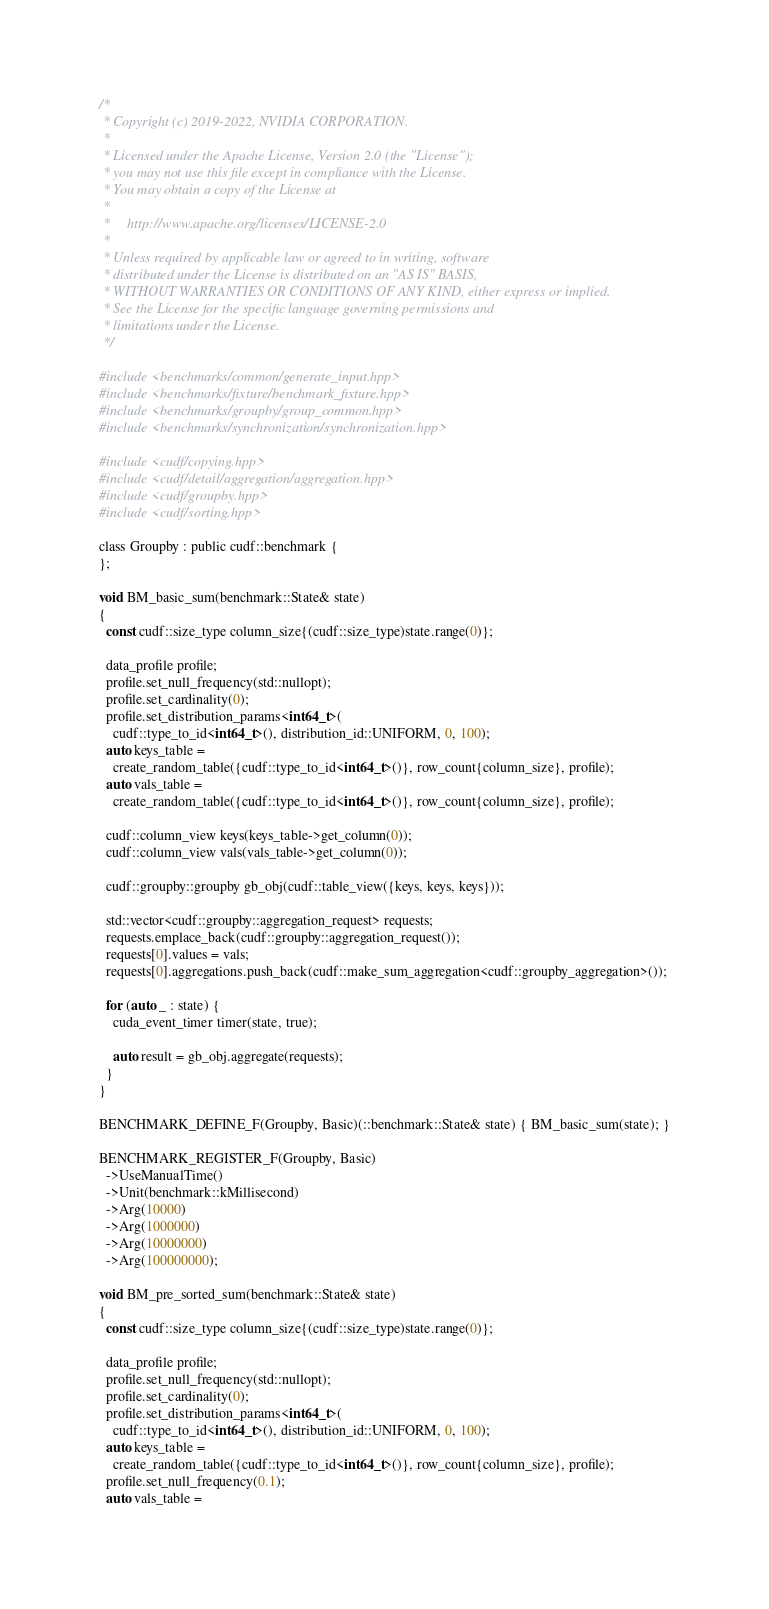Convert code to text. <code><loc_0><loc_0><loc_500><loc_500><_Cuda_>/*
 * Copyright (c) 2019-2022, NVIDIA CORPORATION.
 *
 * Licensed under the Apache License, Version 2.0 (the "License");
 * you may not use this file except in compliance with the License.
 * You may obtain a copy of the License at
 *
 *     http://www.apache.org/licenses/LICENSE-2.0
 *
 * Unless required by applicable law or agreed to in writing, software
 * distributed under the License is distributed on an "AS IS" BASIS,
 * WITHOUT WARRANTIES OR CONDITIONS OF ANY KIND, either express or implied.
 * See the License for the specific language governing permissions and
 * limitations under the License.
 */

#include <benchmarks/common/generate_input.hpp>
#include <benchmarks/fixture/benchmark_fixture.hpp>
#include <benchmarks/groupby/group_common.hpp>
#include <benchmarks/synchronization/synchronization.hpp>

#include <cudf/copying.hpp>
#include <cudf/detail/aggregation/aggregation.hpp>
#include <cudf/groupby.hpp>
#include <cudf/sorting.hpp>

class Groupby : public cudf::benchmark {
};

void BM_basic_sum(benchmark::State& state)
{
  const cudf::size_type column_size{(cudf::size_type)state.range(0)};

  data_profile profile;
  profile.set_null_frequency(std::nullopt);
  profile.set_cardinality(0);
  profile.set_distribution_params<int64_t>(
    cudf::type_to_id<int64_t>(), distribution_id::UNIFORM, 0, 100);
  auto keys_table =
    create_random_table({cudf::type_to_id<int64_t>()}, row_count{column_size}, profile);
  auto vals_table =
    create_random_table({cudf::type_to_id<int64_t>()}, row_count{column_size}, profile);

  cudf::column_view keys(keys_table->get_column(0));
  cudf::column_view vals(vals_table->get_column(0));

  cudf::groupby::groupby gb_obj(cudf::table_view({keys, keys, keys}));

  std::vector<cudf::groupby::aggregation_request> requests;
  requests.emplace_back(cudf::groupby::aggregation_request());
  requests[0].values = vals;
  requests[0].aggregations.push_back(cudf::make_sum_aggregation<cudf::groupby_aggregation>());

  for (auto _ : state) {
    cuda_event_timer timer(state, true);

    auto result = gb_obj.aggregate(requests);
  }
}

BENCHMARK_DEFINE_F(Groupby, Basic)(::benchmark::State& state) { BM_basic_sum(state); }

BENCHMARK_REGISTER_F(Groupby, Basic)
  ->UseManualTime()
  ->Unit(benchmark::kMillisecond)
  ->Arg(10000)
  ->Arg(1000000)
  ->Arg(10000000)
  ->Arg(100000000);

void BM_pre_sorted_sum(benchmark::State& state)
{
  const cudf::size_type column_size{(cudf::size_type)state.range(0)};

  data_profile profile;
  profile.set_null_frequency(std::nullopt);
  profile.set_cardinality(0);
  profile.set_distribution_params<int64_t>(
    cudf::type_to_id<int64_t>(), distribution_id::UNIFORM, 0, 100);
  auto keys_table =
    create_random_table({cudf::type_to_id<int64_t>()}, row_count{column_size}, profile);
  profile.set_null_frequency(0.1);
  auto vals_table =</code> 